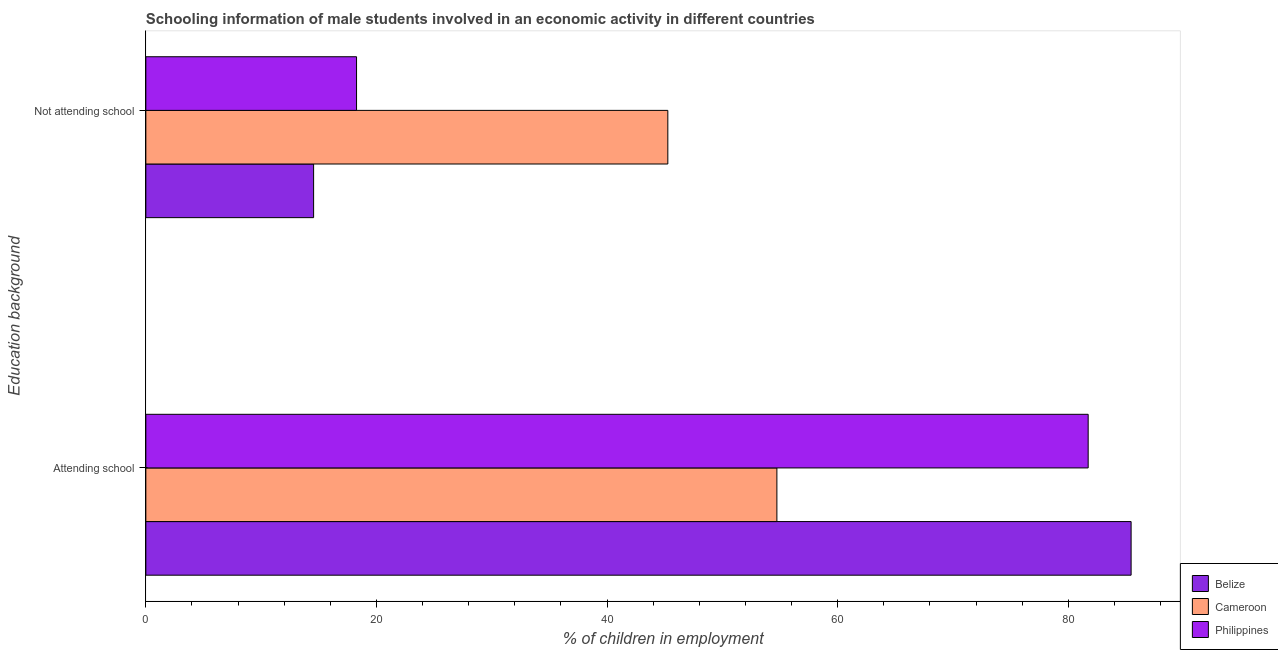How many bars are there on the 1st tick from the top?
Provide a short and direct response. 3. What is the label of the 1st group of bars from the top?
Ensure brevity in your answer.  Not attending school. What is the percentage of employed males who are attending school in Belize?
Your answer should be compact. 85.45. Across all countries, what is the maximum percentage of employed males who are attending school?
Your answer should be compact. 85.45. Across all countries, what is the minimum percentage of employed males who are attending school?
Offer a very short reply. 54.73. In which country was the percentage of employed males who are attending school maximum?
Keep it short and to the point. Belize. In which country was the percentage of employed males who are not attending school minimum?
Make the answer very short. Belize. What is the total percentage of employed males who are not attending school in the graph?
Your answer should be very brief. 78.09. What is the difference between the percentage of employed males who are not attending school in Belize and that in Philippines?
Keep it short and to the point. -3.72. What is the difference between the percentage of employed males who are not attending school in Belize and the percentage of employed males who are attending school in Cameroon?
Your response must be concise. -40.18. What is the average percentage of employed males who are attending school per country?
Your answer should be compact. 73.97. What is the difference between the percentage of employed males who are not attending school and percentage of employed males who are attending school in Cameroon?
Your answer should be very brief. -9.46. In how many countries, is the percentage of employed males who are not attending school greater than 28 %?
Your answer should be very brief. 1. What is the ratio of the percentage of employed males who are attending school in Cameroon to that in Philippines?
Make the answer very short. 0.67. Is the percentage of employed males who are not attending school in Cameroon less than that in Belize?
Provide a short and direct response. No. What does the 1st bar from the bottom in Attending school represents?
Your answer should be very brief. Belize. How many bars are there?
Your answer should be very brief. 6. How many countries are there in the graph?
Give a very brief answer. 3. What is the difference between two consecutive major ticks on the X-axis?
Your response must be concise. 20. Are the values on the major ticks of X-axis written in scientific E-notation?
Your response must be concise. No. Does the graph contain any zero values?
Keep it short and to the point. No. What is the title of the graph?
Your response must be concise. Schooling information of male students involved in an economic activity in different countries. Does "Kenya" appear as one of the legend labels in the graph?
Ensure brevity in your answer.  No. What is the label or title of the X-axis?
Offer a terse response. % of children in employment. What is the label or title of the Y-axis?
Offer a terse response. Education background. What is the % of children in employment of Belize in Attending school?
Offer a terse response. 85.45. What is the % of children in employment in Cameroon in Attending school?
Your answer should be compact. 54.73. What is the % of children in employment in Philippines in Attending school?
Offer a terse response. 81.73. What is the % of children in employment in Belize in Not attending school?
Make the answer very short. 14.55. What is the % of children in employment of Cameroon in Not attending school?
Ensure brevity in your answer.  45.27. What is the % of children in employment in Philippines in Not attending school?
Your response must be concise. 18.27. Across all Education background, what is the maximum % of children in employment of Belize?
Keep it short and to the point. 85.45. Across all Education background, what is the maximum % of children in employment in Cameroon?
Your response must be concise. 54.73. Across all Education background, what is the maximum % of children in employment in Philippines?
Give a very brief answer. 81.73. Across all Education background, what is the minimum % of children in employment of Belize?
Make the answer very short. 14.55. Across all Education background, what is the minimum % of children in employment of Cameroon?
Provide a succinct answer. 45.27. Across all Education background, what is the minimum % of children in employment of Philippines?
Offer a terse response. 18.27. What is the total % of children in employment in Cameroon in the graph?
Make the answer very short. 100. What is the total % of children in employment in Philippines in the graph?
Offer a terse response. 100. What is the difference between the % of children in employment of Belize in Attending school and that in Not attending school?
Provide a succinct answer. 70.9. What is the difference between the % of children in employment in Cameroon in Attending school and that in Not attending school?
Ensure brevity in your answer.  9.46. What is the difference between the % of children in employment in Philippines in Attending school and that in Not attending school?
Keep it short and to the point. 63.45. What is the difference between the % of children in employment in Belize in Attending school and the % of children in employment in Cameroon in Not attending school?
Keep it short and to the point. 40.18. What is the difference between the % of children in employment of Belize in Attending school and the % of children in employment of Philippines in Not attending school?
Your answer should be very brief. 67.18. What is the difference between the % of children in employment of Cameroon in Attending school and the % of children in employment of Philippines in Not attending school?
Your answer should be very brief. 36.46. What is the average % of children in employment in Belize per Education background?
Make the answer very short. 50. What is the average % of children in employment of Cameroon per Education background?
Offer a very short reply. 50. What is the average % of children in employment of Philippines per Education background?
Ensure brevity in your answer.  50. What is the difference between the % of children in employment in Belize and % of children in employment in Cameroon in Attending school?
Your answer should be very brief. 30.72. What is the difference between the % of children in employment of Belize and % of children in employment of Philippines in Attending school?
Your response must be concise. 3.72. What is the difference between the % of children in employment in Cameroon and % of children in employment in Philippines in Attending school?
Provide a short and direct response. -27. What is the difference between the % of children in employment in Belize and % of children in employment in Cameroon in Not attending school?
Give a very brief answer. -30.72. What is the difference between the % of children in employment in Belize and % of children in employment in Philippines in Not attending school?
Keep it short and to the point. -3.72. What is the difference between the % of children in employment in Cameroon and % of children in employment in Philippines in Not attending school?
Keep it short and to the point. 27. What is the ratio of the % of children in employment of Belize in Attending school to that in Not attending school?
Provide a short and direct response. 5.87. What is the ratio of the % of children in employment in Cameroon in Attending school to that in Not attending school?
Your response must be concise. 1.21. What is the ratio of the % of children in employment in Philippines in Attending school to that in Not attending school?
Provide a succinct answer. 4.47. What is the difference between the highest and the second highest % of children in employment of Belize?
Give a very brief answer. 70.9. What is the difference between the highest and the second highest % of children in employment in Cameroon?
Offer a very short reply. 9.46. What is the difference between the highest and the second highest % of children in employment in Philippines?
Give a very brief answer. 63.45. What is the difference between the highest and the lowest % of children in employment in Belize?
Your answer should be very brief. 70.9. What is the difference between the highest and the lowest % of children in employment of Cameroon?
Your answer should be very brief. 9.46. What is the difference between the highest and the lowest % of children in employment in Philippines?
Keep it short and to the point. 63.45. 